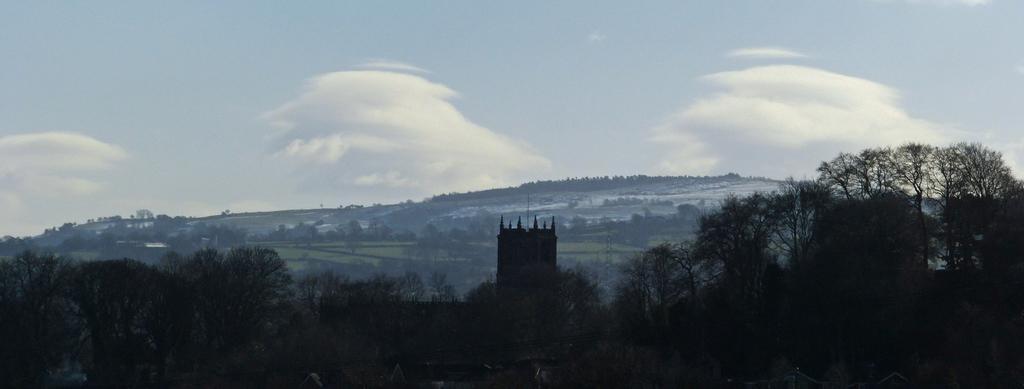How would you summarize this image in a sentence or two? In this image, there are hills, trees, fields and a tower. In the background, there is the sky. 